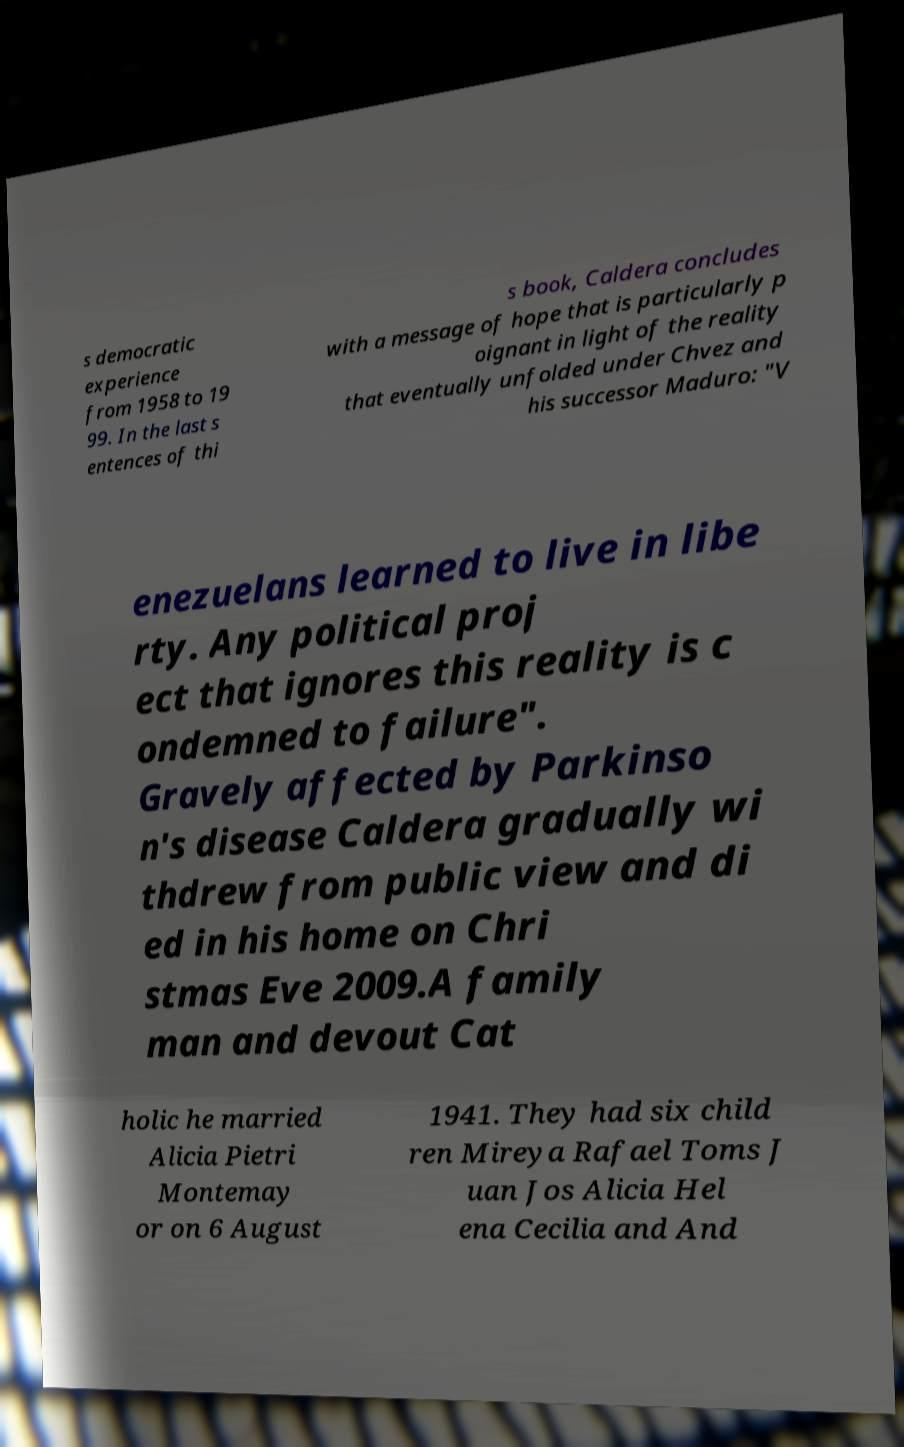Please read and relay the text visible in this image. What does it say? s democratic experience from 1958 to 19 99. In the last s entences of thi s book, Caldera concludes with a message of hope that is particularly p oignant in light of the reality that eventually unfolded under Chvez and his successor Maduro: "V enezuelans learned to live in libe rty. Any political proj ect that ignores this reality is c ondemned to failure". Gravely affected by Parkinso n's disease Caldera gradually wi thdrew from public view and di ed in his home on Chri stmas Eve 2009.A family man and devout Cat holic he married Alicia Pietri Montemay or on 6 August 1941. They had six child ren Mireya Rafael Toms J uan Jos Alicia Hel ena Cecilia and And 